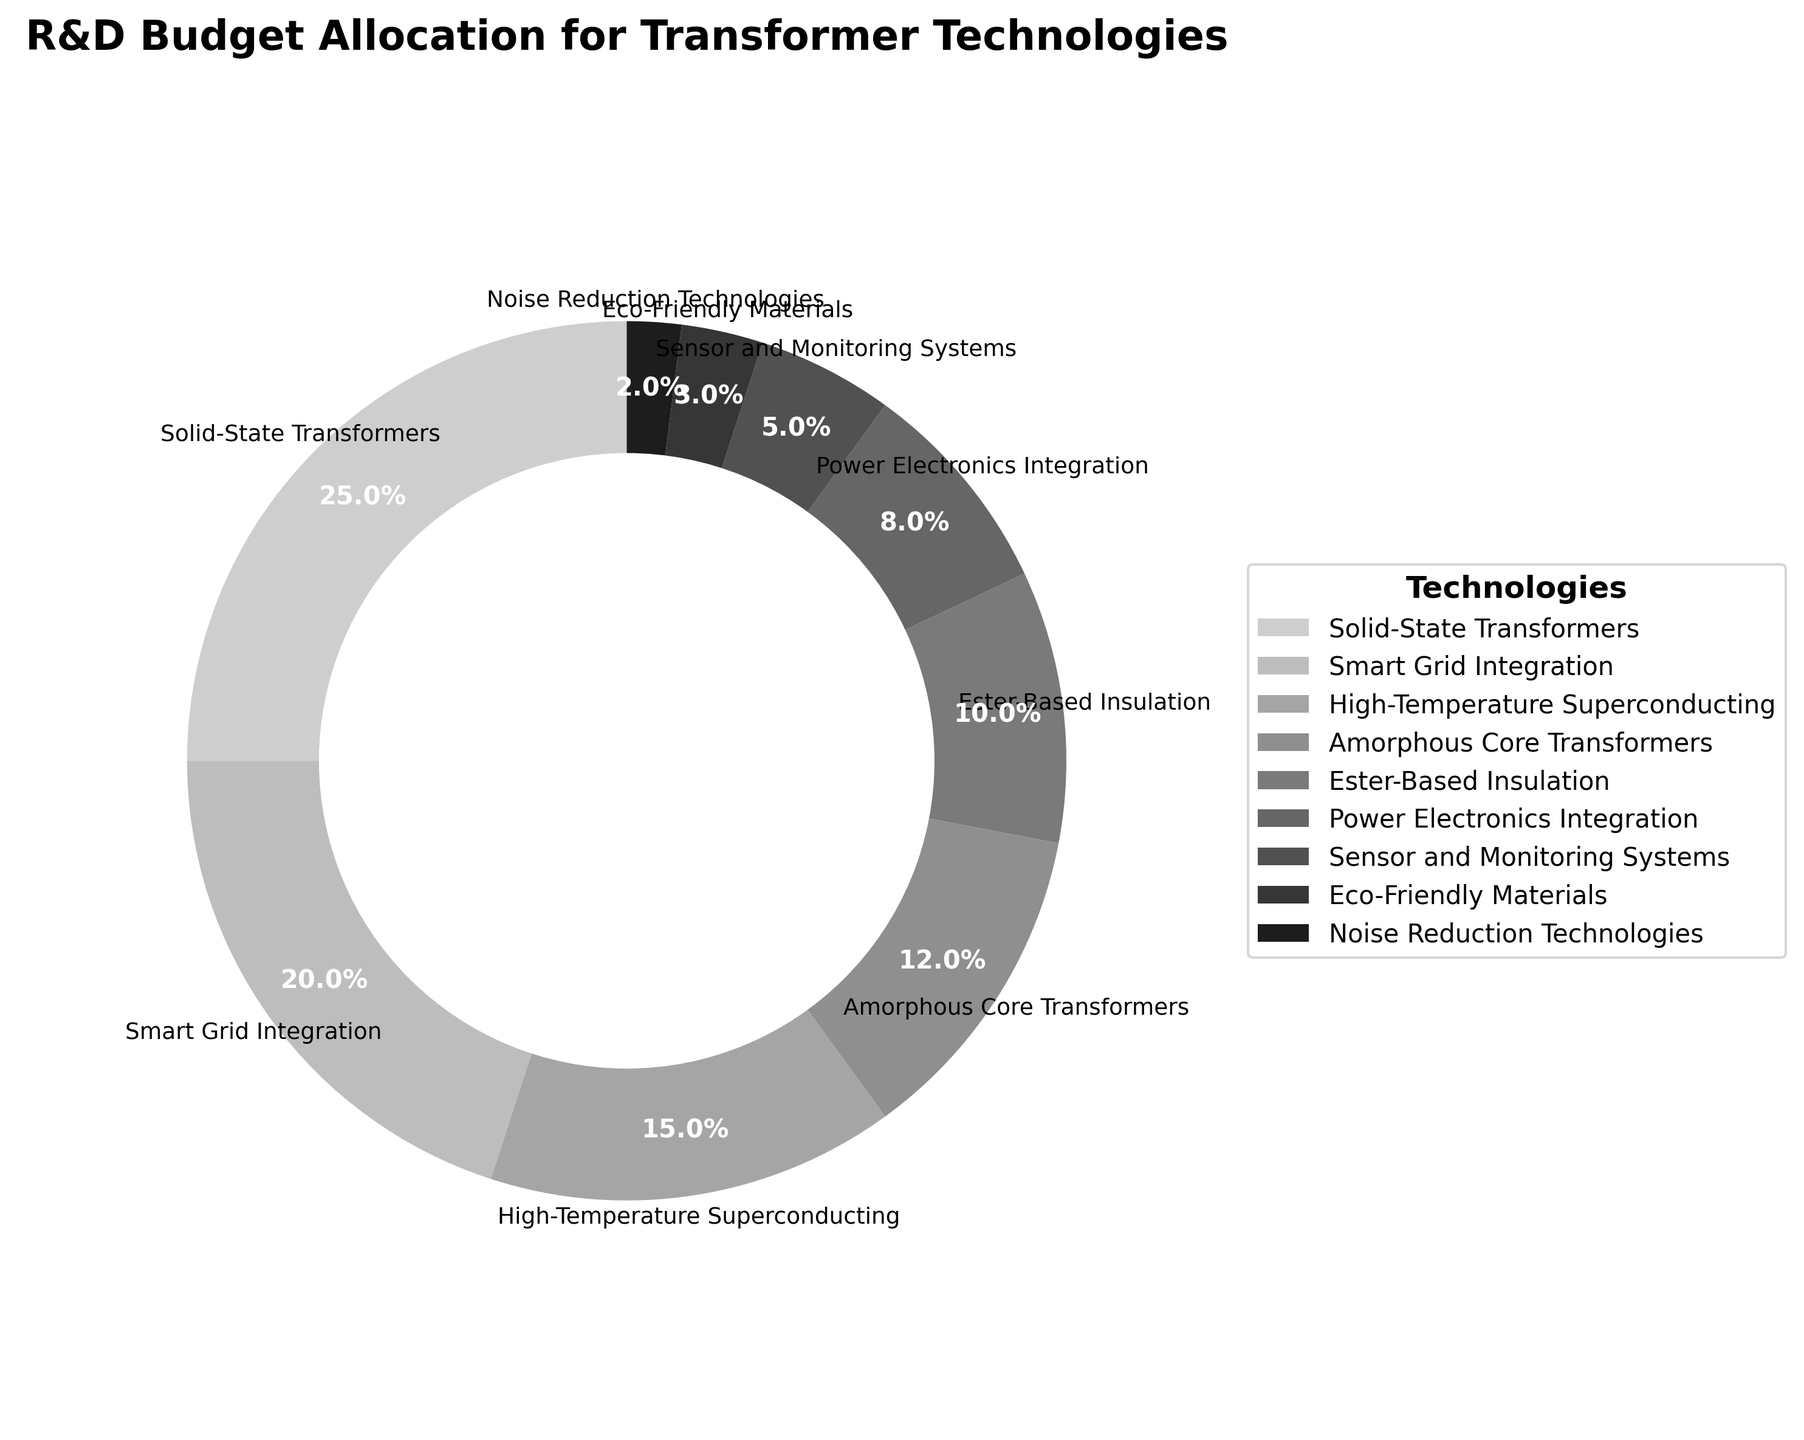Which technology received the highest R&D budget allocation? The pie chart shows various proportions for each technology, and the largest segment is for Solid-State Transformers.
Answer: Solid-State Transformers What is the total budget allocation for Smart Grid Integration and High-Temperature Superconducting combined? According to the pie chart, Smart Grid Integration has 20% and High-Temperature Superconducting has 15%. Adding these together gives 20% + 15%.
Answer: 35% Which technology received a lower budget allocation: Noise Reduction Technologies or Sensor and Monitoring Systems? By comparing the pie chart segments, Noise Reduction Technologies has a smaller slice at 2%, whereas Sensor and Monitoring Systems has a larger slice at 5%.
Answer: Noise Reduction Technologies How much more budget allocation does Solid-State Transformers have compared to Ester-Based Insulation? The chart indicates that Solid-State Transformers have 25% and Ester-Based Insulation has 10%. The difference is calculated as 25% - 10%.
Answer: 15% What technologies combined account for less than 10% of the budget allocation each? From examining the pie chart, the technologies with less than 10% each are Power Electronics Integration (8%), Sensor and Monitoring Systems (5%), Eco-Friendly Materials (3%), and Noise Reduction Technologies (2%).
Answer: Power Electronics Integration, Sensor and Monitoring Systems, Eco-Friendly Materials, Noise Reduction Technologies Which two technologies have the closest budget allocations? By reviewing the segments visually on the pie chart, Smart Grid Integration at 20% and High-Temperature Superconducting at 15% are the closest in allocation.
Answer: Smart Grid Integration and High-Temperature Superconducting What is the combined allocation percentage for Amorphous Core Transformers, Ester-Based Insulation, and Eco-Friendly Materials? Summing up the percentages from the pie chart: Amorphous Core Transformers (12%), Ester-Based Insulation (10%), and Eco-Friendly Materials (3%) gives 12% + 10% + 3%.
Answer: 25% What fraction of the total R&D budget is allocated to technologies aimed at improving transformer materials (Amorphous Core Transformers and Eco-Friendly Materials)? Adding the percentages of Amorphous Core Transformers (12%) and Eco-Friendly Materials (3%) from the pie chart results in 12% + 3%.
Answer: 15% Compare the budget allocation for Power Electronics Integration and Amorphous Core Transformers. Which one is greater and by how much? According to the pie chart, Power Electronics Integration has 8% while Amorphous Core Transformers have 12%. The difference is 12% - 8%.
Answer: Amorphous Core Transformers by 4% What is the ratio of the budget allocation of Sensor and Monitoring Systems to Eco-Friendly Materials? From the pie chart, Sensor and Monitoring Systems have 5% and Eco-Friendly Materials have 3%. The ratio is 5% divided by 3%.
Answer: 5:3 